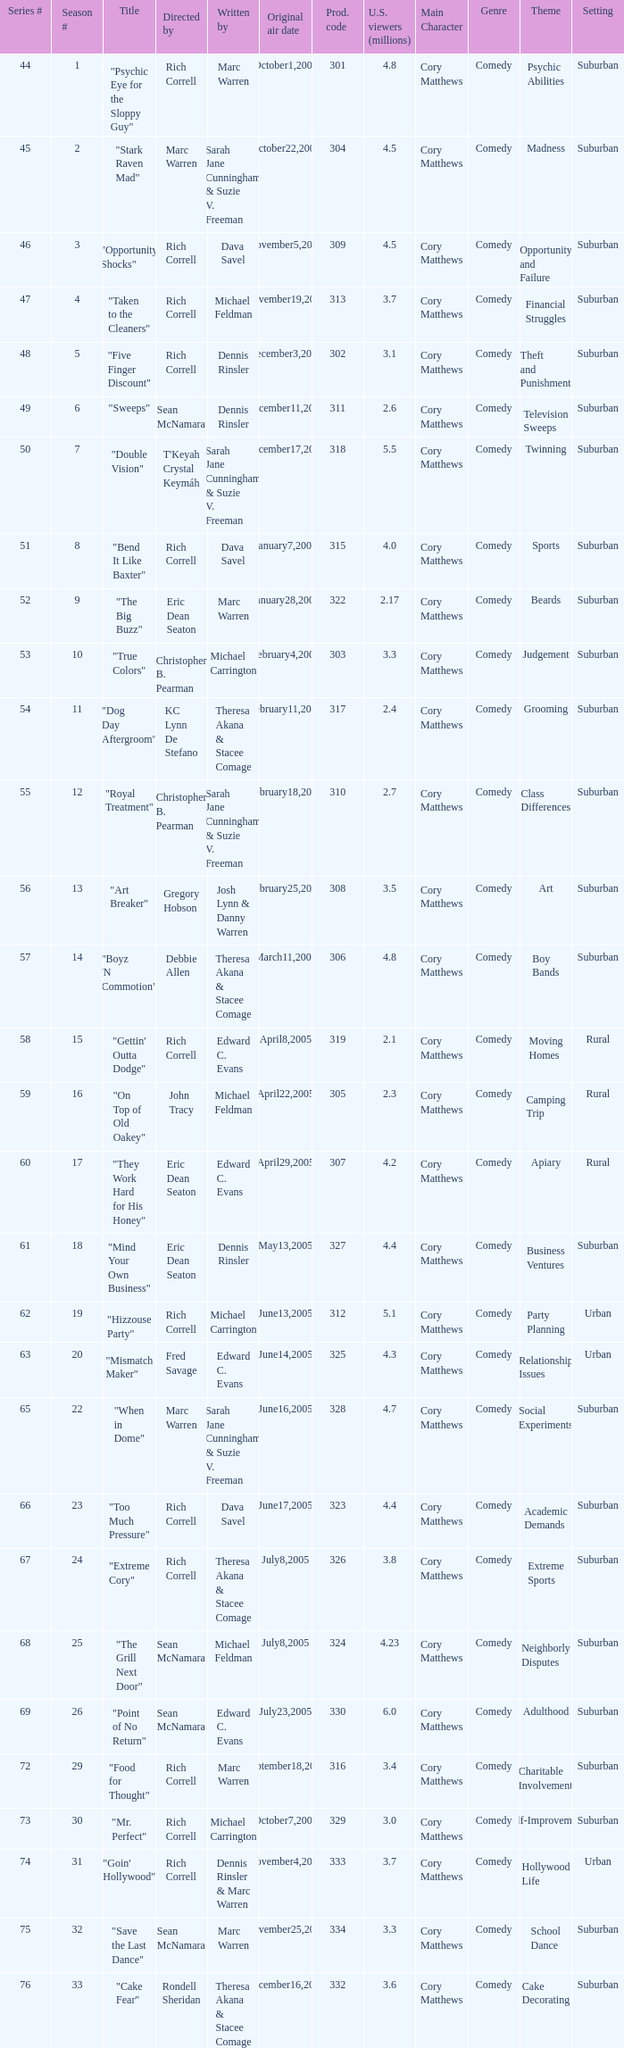What was the production code for the episode helmed by rondell sheridan? 332.0. 